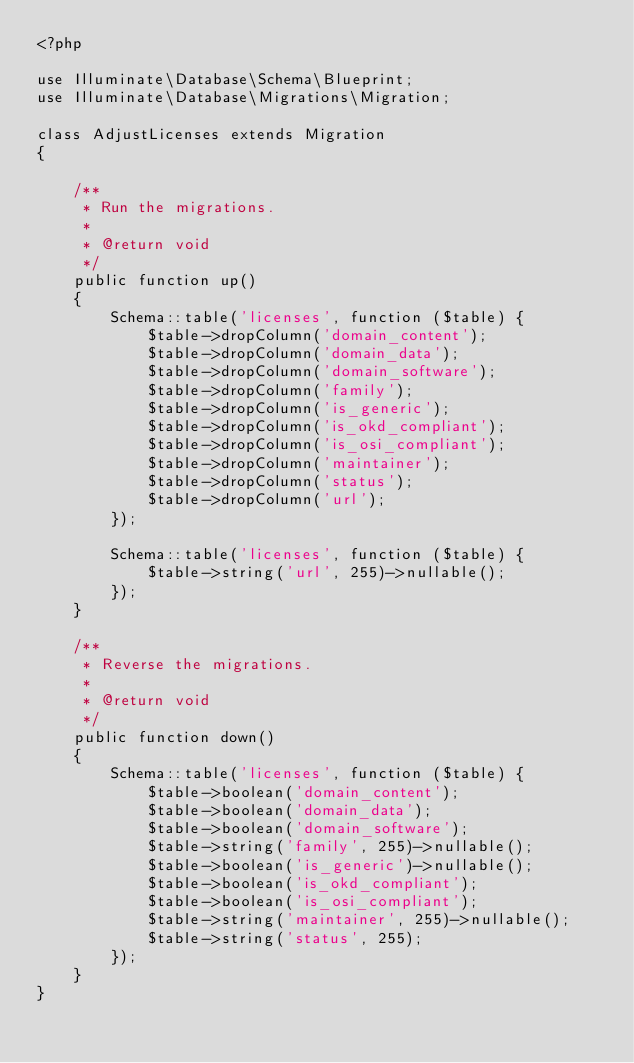<code> <loc_0><loc_0><loc_500><loc_500><_PHP_><?php

use Illuminate\Database\Schema\Blueprint;
use Illuminate\Database\Migrations\Migration;

class AdjustLicenses extends Migration
{

    /**
     * Run the migrations.
     *
     * @return void
     */
    public function up()
    {
        Schema::table('licenses', function ($table) {
            $table->dropColumn('domain_content');
            $table->dropColumn('domain_data');
            $table->dropColumn('domain_software');
            $table->dropColumn('family');
            $table->dropColumn('is_generic');
            $table->dropColumn('is_okd_compliant');
            $table->dropColumn('is_osi_compliant');
            $table->dropColumn('maintainer');
            $table->dropColumn('status');
            $table->dropColumn('url');
        });

        Schema::table('licenses', function ($table) {
            $table->string('url', 255)->nullable();
        });
    }

    /**
     * Reverse the migrations.
     *
     * @return void
     */
    public function down()
    {
        Schema::table('licenses', function ($table) {
            $table->boolean('domain_content');
            $table->boolean('domain_data');
            $table->boolean('domain_software');
            $table->string('family', 255)->nullable();
            $table->boolean('is_generic')->nullable();
            $table->boolean('is_okd_compliant');
            $table->boolean('is_osi_compliant');
            $table->string('maintainer', 255)->nullable();
            $table->string('status', 255);
        });
    }
}
</code> 